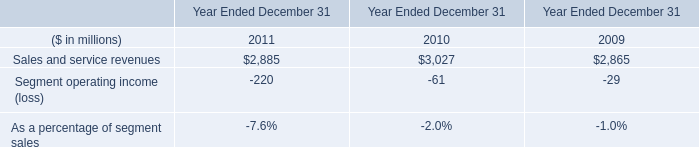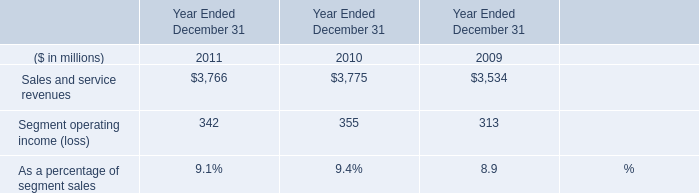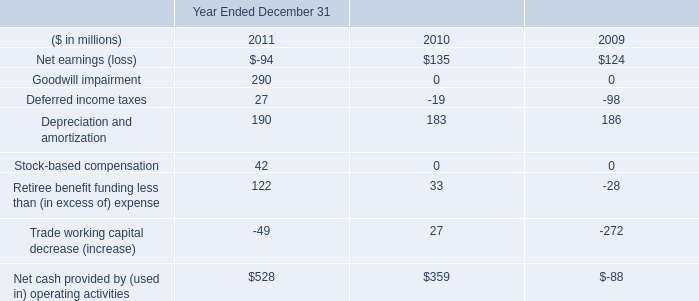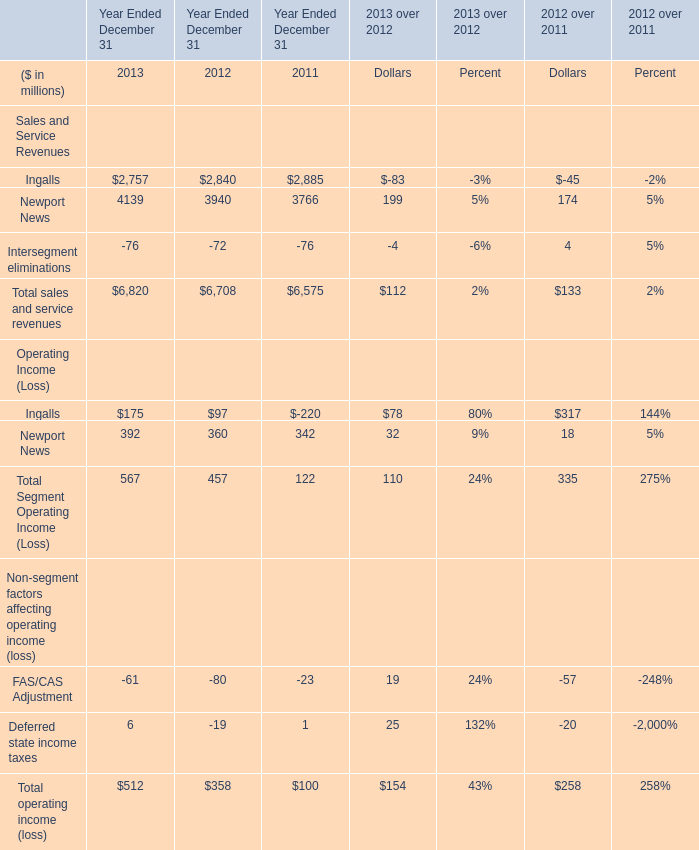What was the sum of Sales and Service Revenues without those Sales and Service Revenues smaller than 0, in 2013? (in millions) 
Computations: (2757 + 4139)
Answer: 6896.0. 